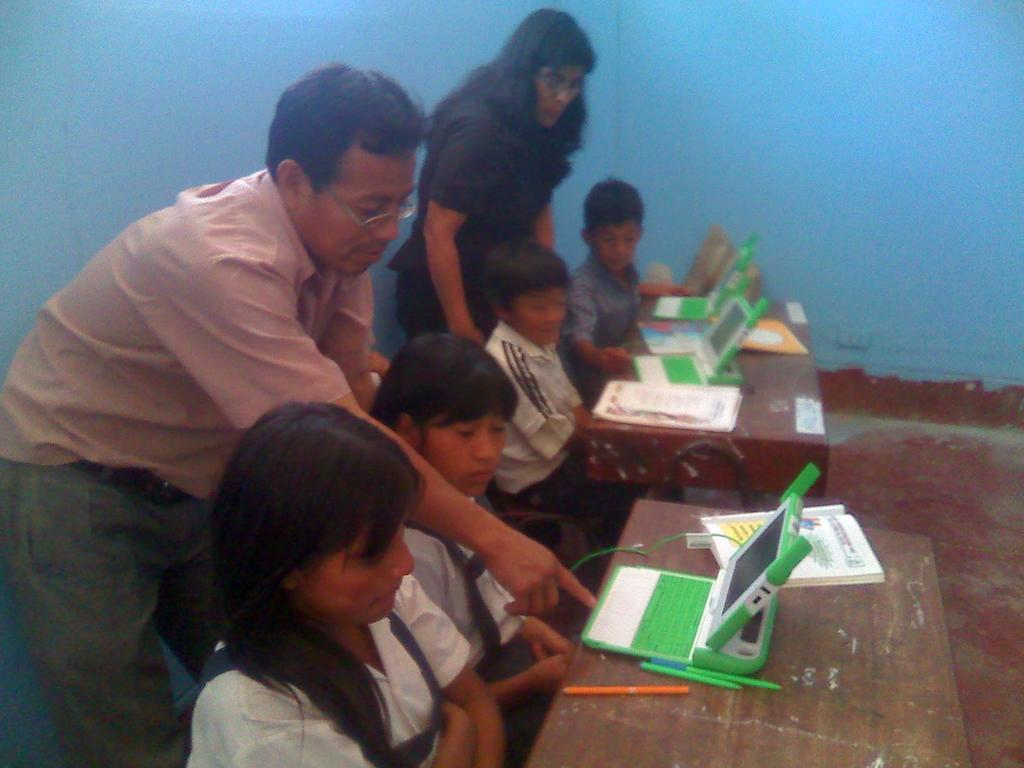What are the children doing in the image? The children are sitting in the image. What objects are in front of the children? There are tables in front of the children. What electronic devices are on the tables? Laptops are present on the tables. What else is on the tables besides laptops? Books and pens are on the tables. How many people are standing in the image? Two people are standing in the image. What can be seen in the background of the image? There is a wall in the background of the image. What letter can be seen on the table in the image? There is no letter present on the table in the image. What type of bead is being used by the children in the image? There are no beads present in the image. Can you see a badge on any of the people in the image? There is no badge visible on any of the people in the image. 